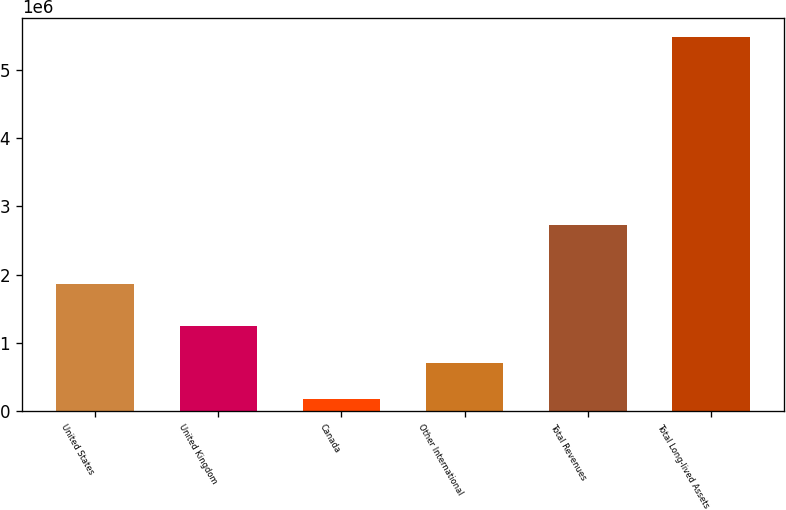Convert chart. <chart><loc_0><loc_0><loc_500><loc_500><bar_chart><fcel>United States<fcel>United Kingdom<fcel>Canada<fcel>Other International<fcel>Total Revenues<fcel>Total Long-lived Assets<nl><fcel>1.86281e+06<fcel>1.24081e+06<fcel>179636<fcel>710225<fcel>2.73004e+06<fcel>5.48552e+06<nl></chart> 